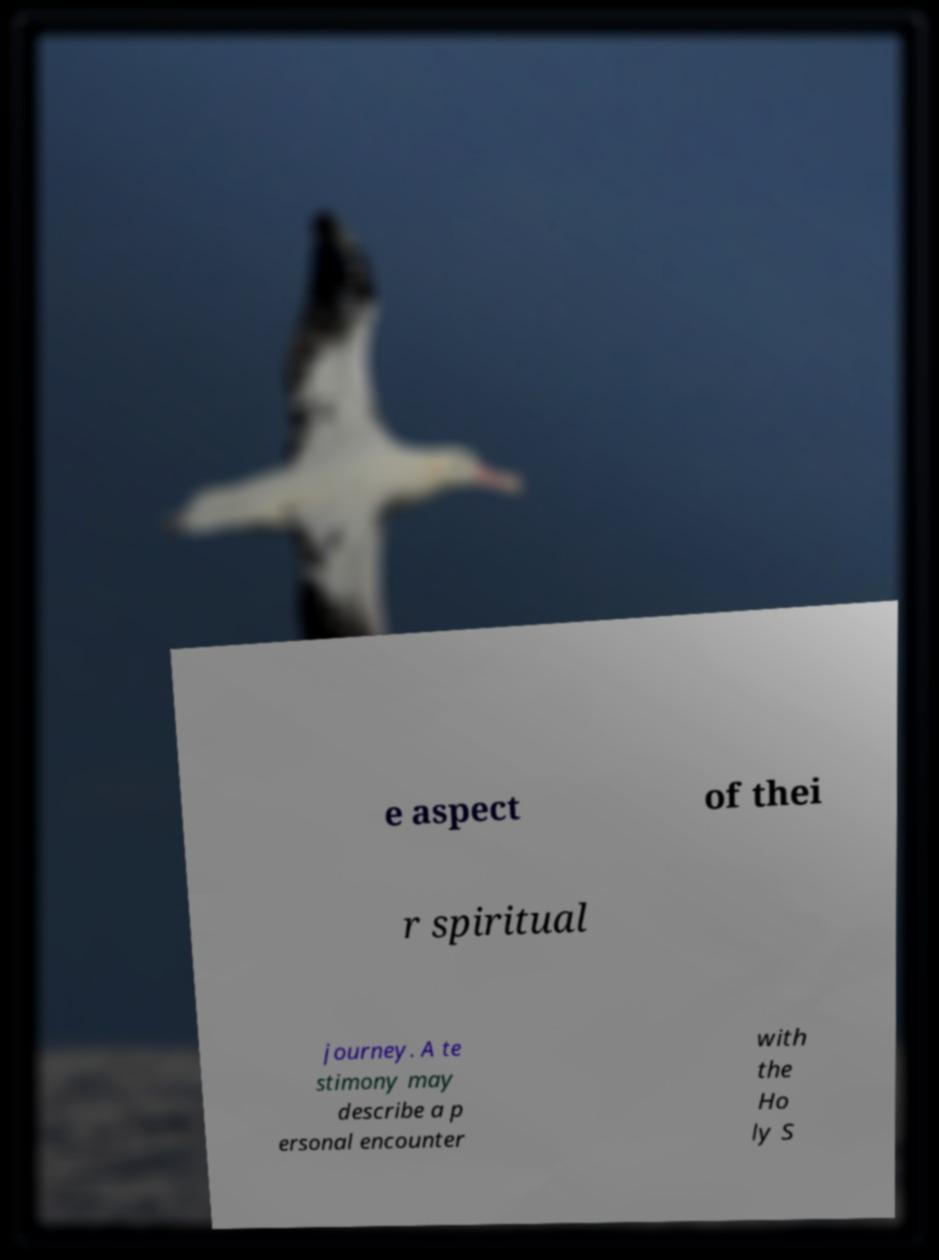Could you extract and type out the text from this image? e aspect of thei r spiritual journey. A te stimony may describe a p ersonal encounter with the Ho ly S 